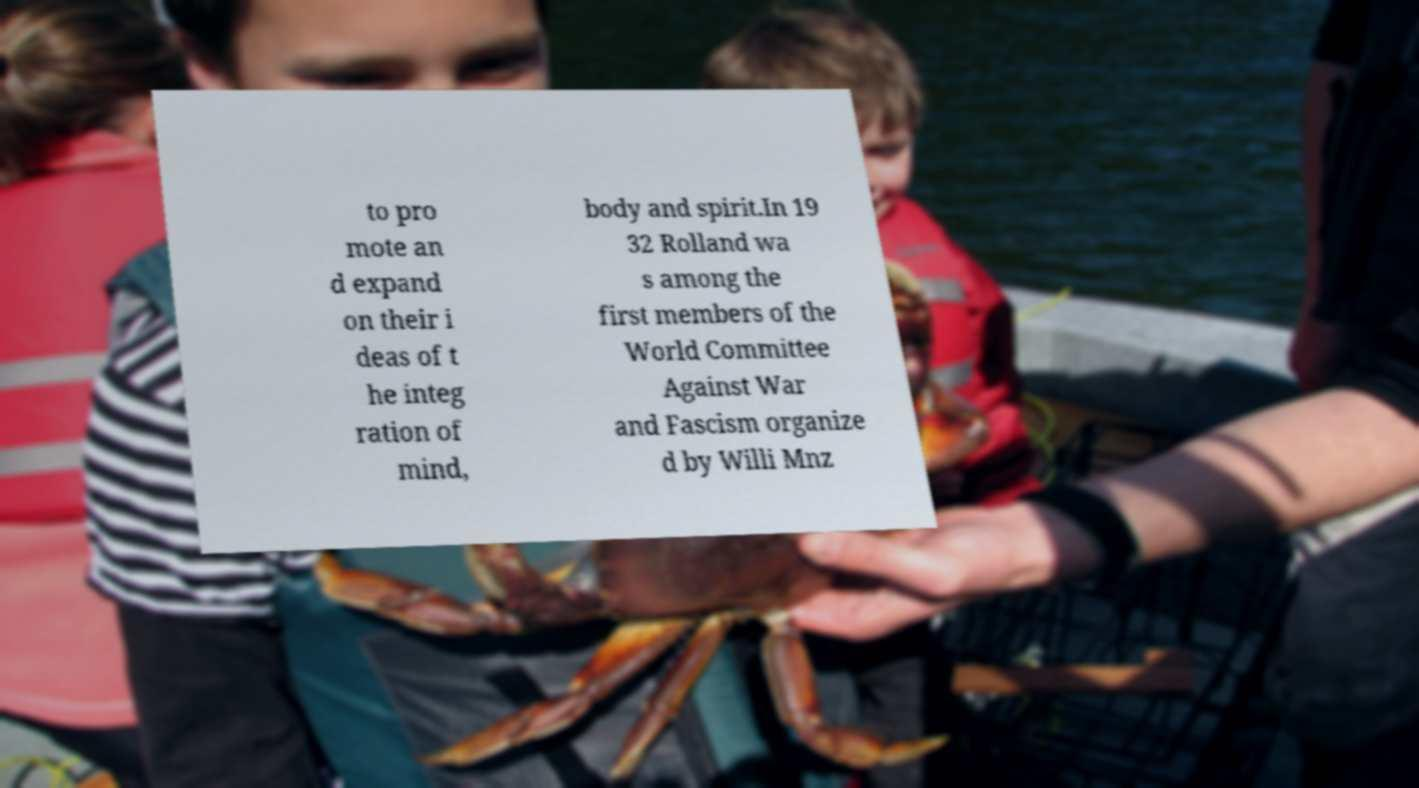For documentation purposes, I need the text within this image transcribed. Could you provide that? to pro mote an d expand on their i deas of t he integ ration of mind, body and spirit.In 19 32 Rolland wa s among the first members of the World Committee Against War and Fascism organize d by Willi Mnz 